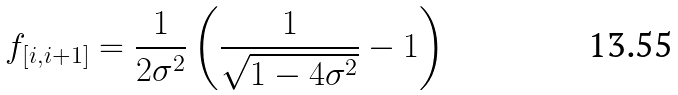Convert formula to latex. <formula><loc_0><loc_0><loc_500><loc_500>f _ { [ i , i + 1 ] } = \frac { 1 } { 2 \sigma ^ { 2 } } \left ( \frac { 1 } { \sqrt { 1 - 4 \sigma ^ { 2 } } } - 1 \right )</formula> 